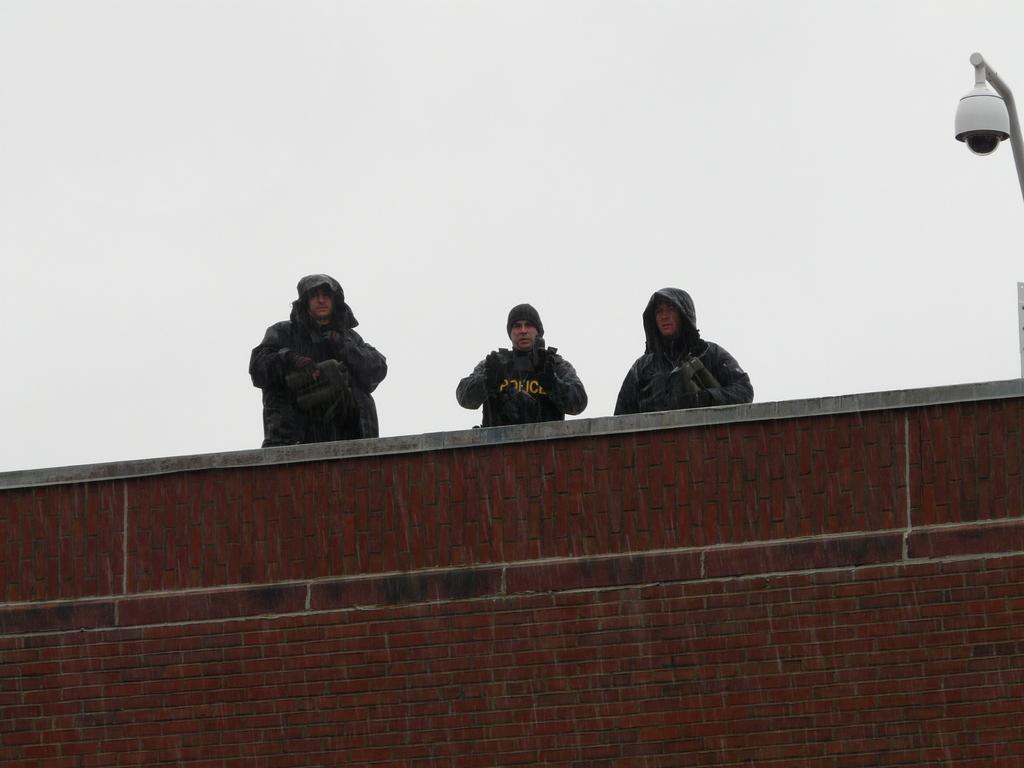Could you give a brief overview of what you see in this image? There is a brick wall. 3 people are standing on the top. There is a light at the right. 